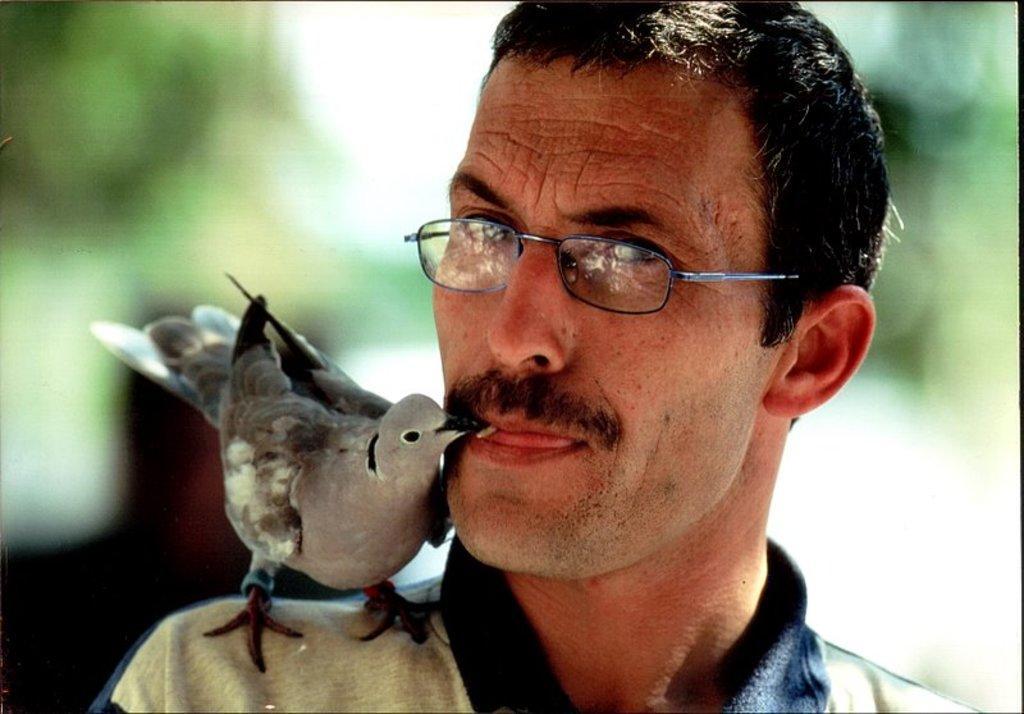Can you describe this image briefly? In this image, we can see a bird on the person. This person is wearing clothes and spectacles. In the background, image is blurred. 